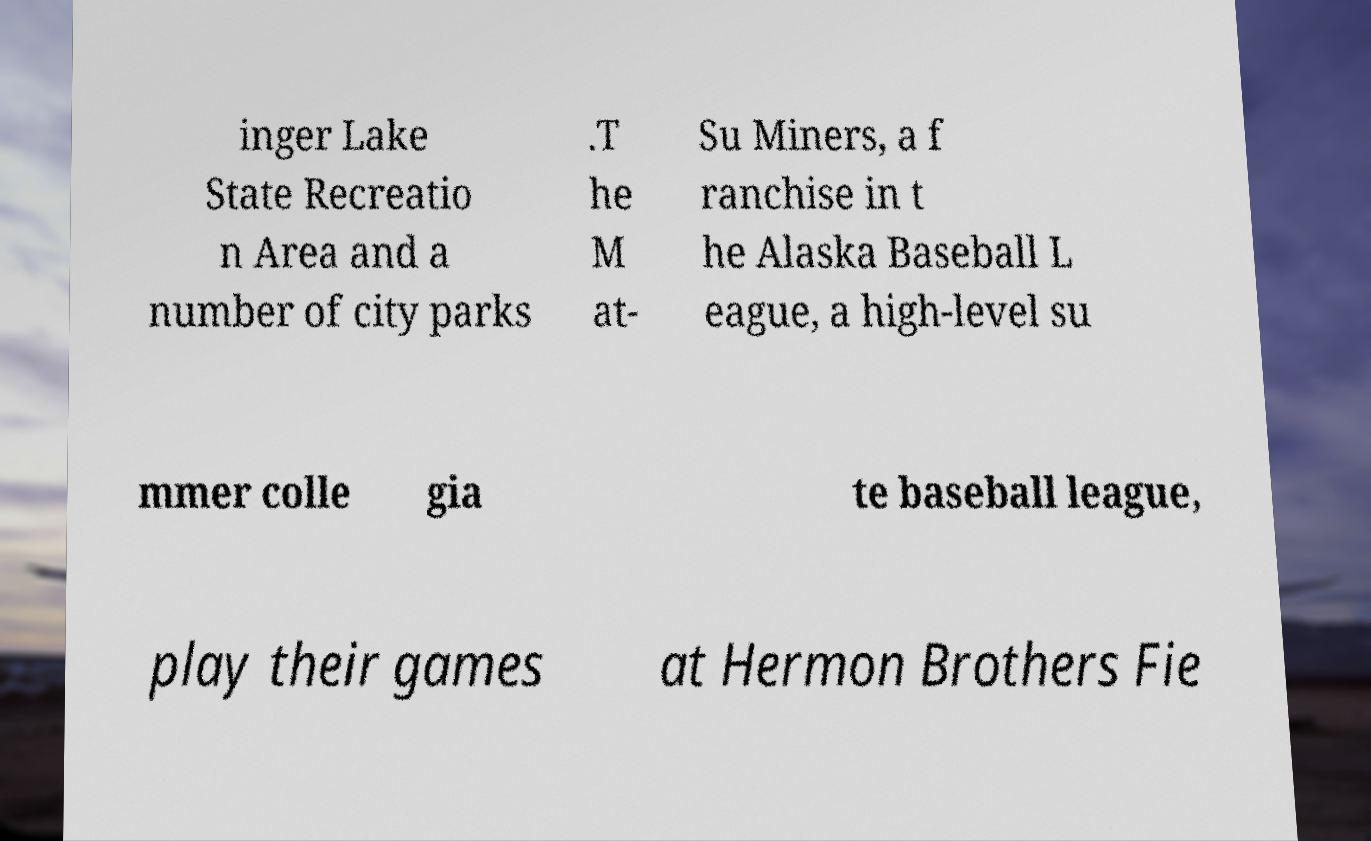I need the written content from this picture converted into text. Can you do that? inger Lake State Recreatio n Area and a number of city parks .T he M at- Su Miners, a f ranchise in t he Alaska Baseball L eague, a high-level su mmer colle gia te baseball league, play their games at Hermon Brothers Fie 